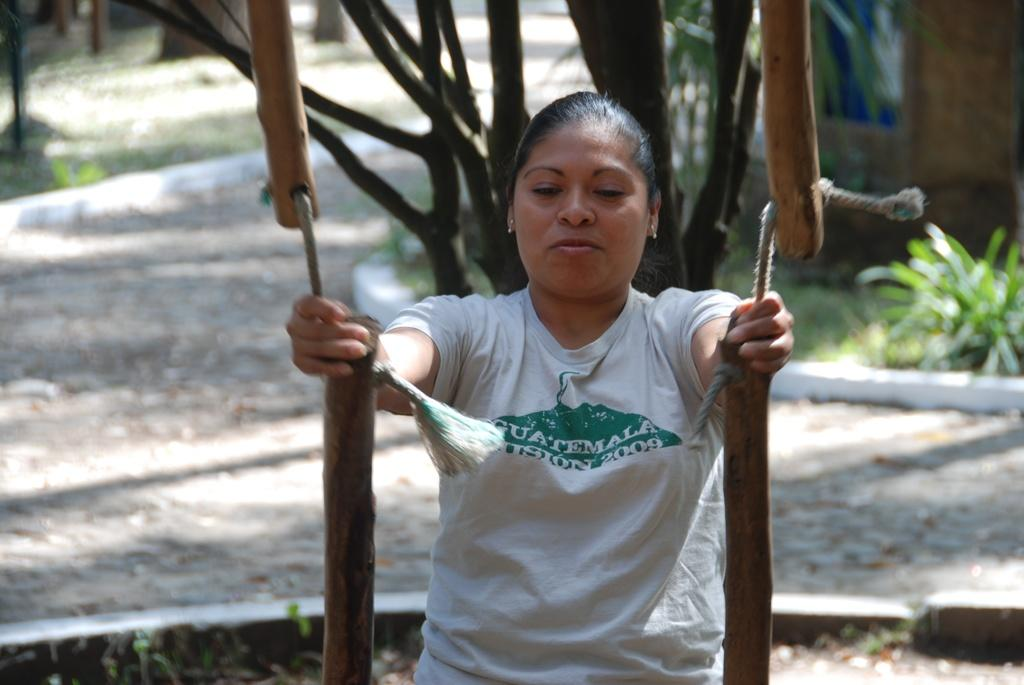Who or what is the main subject in the image? There is a person in the image. What is the person wearing? The person is wearing a white shirt. What can be seen in the background of the image? There are trees in the background of the image. What is the color of the trees? The trees are green in color. Can you see the cat taking a breath in the image? There is no cat present in the image, and therefore no such activity can be observed. 